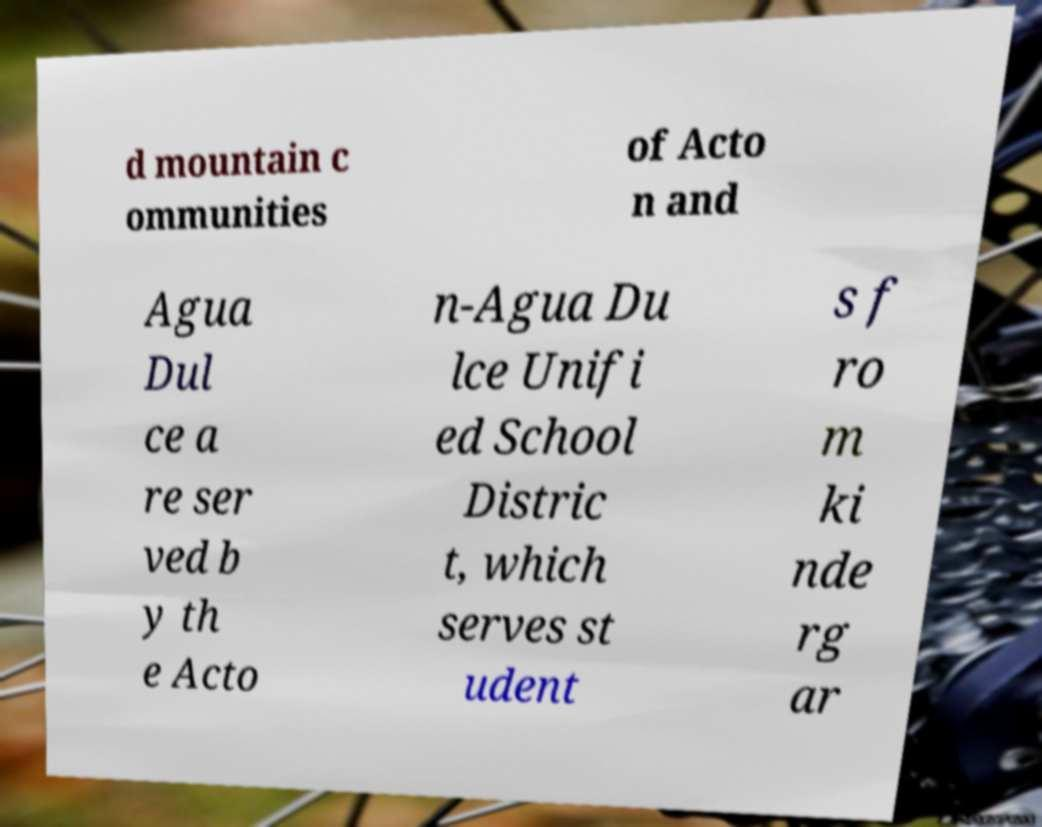What messages or text are displayed in this image? I need them in a readable, typed format. d mountain c ommunities of Acto n and Agua Dul ce a re ser ved b y th e Acto n-Agua Du lce Unifi ed School Distric t, which serves st udent s f ro m ki nde rg ar 